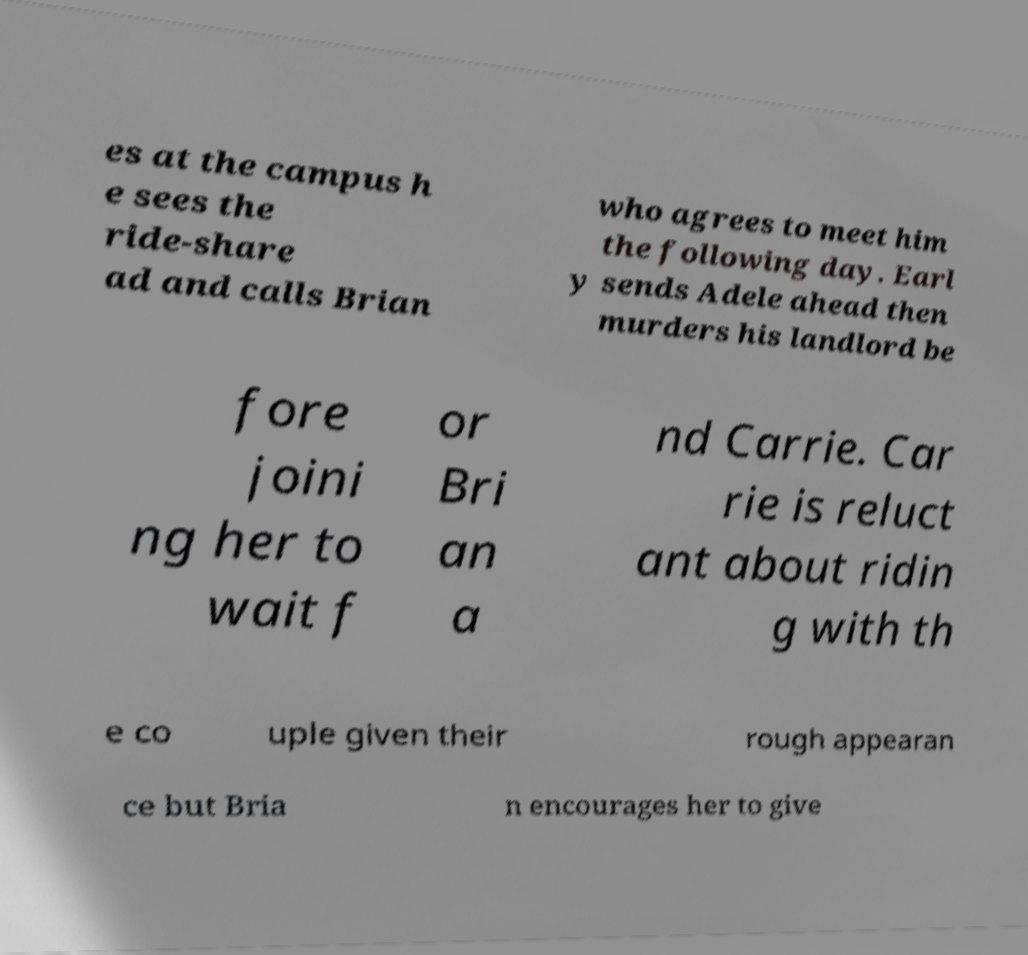For documentation purposes, I need the text within this image transcribed. Could you provide that? es at the campus h e sees the ride-share ad and calls Brian who agrees to meet him the following day. Earl y sends Adele ahead then murders his landlord be fore joini ng her to wait f or Bri an a nd Carrie. Car rie is reluct ant about ridin g with th e co uple given their rough appearan ce but Bria n encourages her to give 